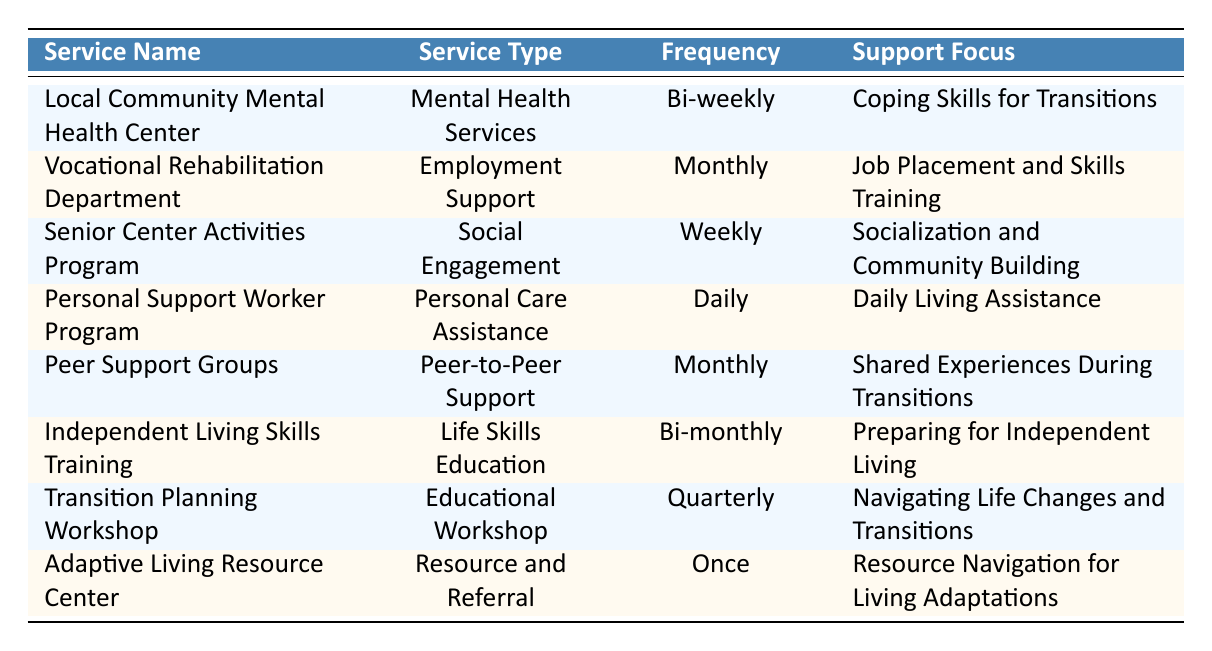What is the service type for the "Local Community Mental Health Center"? The table displays the service type for each service listed. For the "Local Community Mental Health Center," the corresponding service type is listed as "Mental Health Services."
Answer: Mental Health Services How often is the "Independent Living Skills Training" accessed? By examining the frequency column for the "Independent Living Skills Training," it is shown to be accessed "Bi-monthly."
Answer: Bi-monthly Which service focuses on "Coping Skills for Transitions"? Looking at the support focus column, the service that focuses on "Coping Skills for Transitions" is the "Local Community Mental Health Center."
Answer: Local Community Mental Health Center Did the "Crisis Intervention Hotline" get accessed in the past year? The table indicates whether each service was accessed in the past year. For the "Crisis Intervention Hotline," the value is "false," meaning it was not accessed.
Answer: No What is the frequency of the "Senior Center Activities Program"? The frequency of "Senior Center Activities Program" can be found in the frequency column of the table, showing that it is accessed "Weekly."
Answer: Weekly How many services were accessed in the past year? To find the total number of services accessed in the past year, we need to count the services marked as "true" in the accessed column. From the table, there are 7 services that were accessed.
Answer: 7 Which service has the highest frequency of access? Checking the frequencies, the "Personal Support Worker Program" has the highest frequency of access, listed as "Daily."
Answer: Daily Are there more services focused on social engagement or mental health services? To answer, we calculate the number of services in each category. There are 3 services for social engagement ("Senior Center Activities Program"), and 2 for mental health services ("Local Community Mental Health Center"). Thus, social engagement services are more prevalent.
Answer: Social Engagement What is the support focus of the service accessed monthly? Reviewing the table, both "Vocational Rehabilitation Department" and "Peer Support Groups" are accessed monthly, focusing on "Job Placement and Skills Training" and "Shared Experiences During Transitions," respectively.
Answer: Job Placement and Skills Training; Shared Experiences During Transitions Which service provides support for "Preparing for Independent Living"? By looking at the support focus column, the service that provides support for "Preparing for Independent Living" is the "Independent Living Skills Training."
Answer: Independent Living Skills Training 